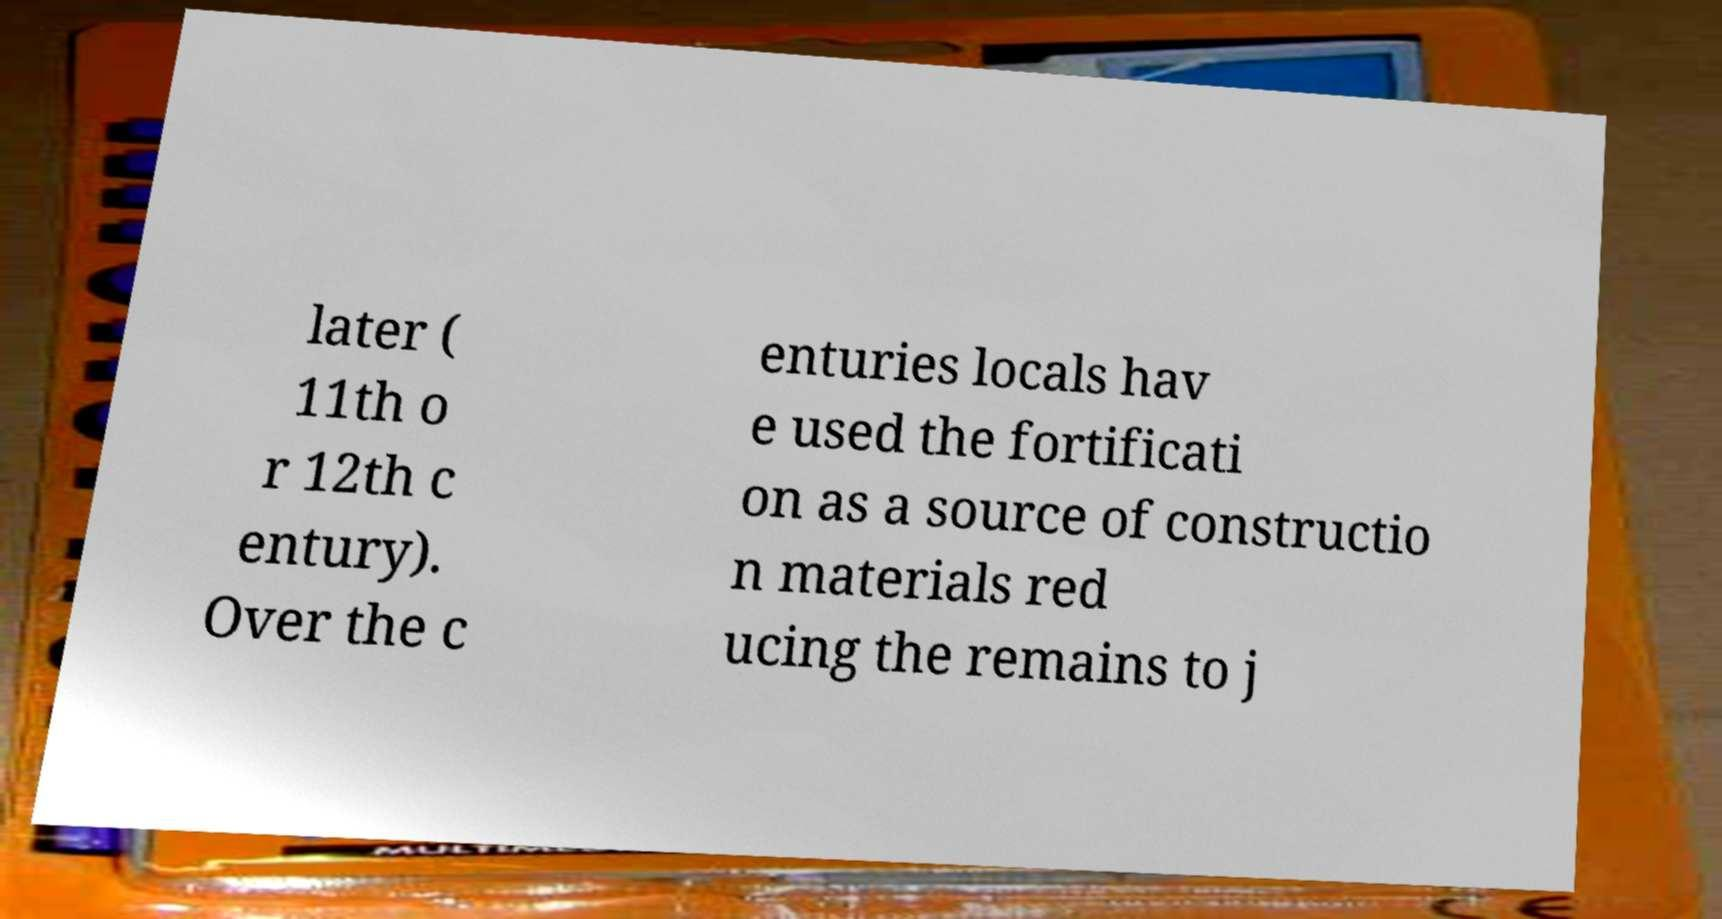Please identify and transcribe the text found in this image. later ( 11th o r 12th c entury). Over the c enturies locals hav e used the fortificati on as a source of constructio n materials red ucing the remains to j 